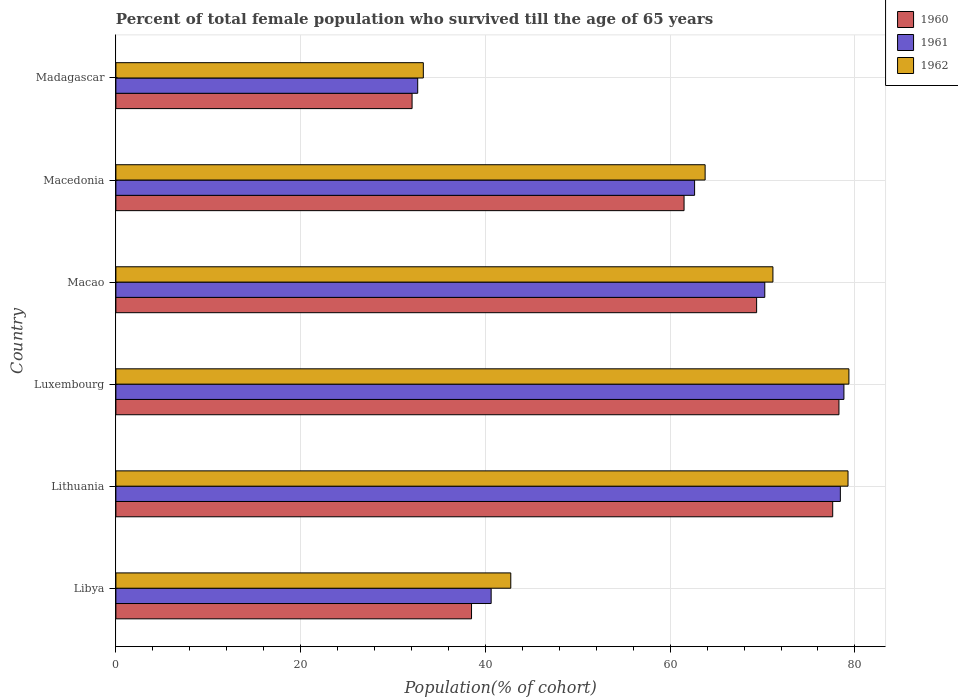How many groups of bars are there?
Make the answer very short. 6. Are the number of bars per tick equal to the number of legend labels?
Give a very brief answer. Yes. How many bars are there on the 4th tick from the top?
Your response must be concise. 3. How many bars are there on the 3rd tick from the bottom?
Offer a very short reply. 3. What is the label of the 2nd group of bars from the top?
Offer a very short reply. Macedonia. What is the percentage of total female population who survived till the age of 65 years in 1961 in Luxembourg?
Provide a short and direct response. 78.81. Across all countries, what is the maximum percentage of total female population who survived till the age of 65 years in 1961?
Your answer should be compact. 78.81. Across all countries, what is the minimum percentage of total female population who survived till the age of 65 years in 1960?
Provide a short and direct response. 32.06. In which country was the percentage of total female population who survived till the age of 65 years in 1961 maximum?
Provide a succinct answer. Luxembourg. In which country was the percentage of total female population who survived till the age of 65 years in 1960 minimum?
Your answer should be compact. Madagascar. What is the total percentage of total female population who survived till the age of 65 years in 1961 in the graph?
Your answer should be very brief. 363.42. What is the difference between the percentage of total female population who survived till the age of 65 years in 1962 in Lithuania and that in Madagascar?
Keep it short and to the point. 45.97. What is the difference between the percentage of total female population who survived till the age of 65 years in 1961 in Libya and the percentage of total female population who survived till the age of 65 years in 1960 in Lithuania?
Your answer should be very brief. -36.97. What is the average percentage of total female population who survived till the age of 65 years in 1960 per country?
Your answer should be very brief. 59.55. What is the difference between the percentage of total female population who survived till the age of 65 years in 1961 and percentage of total female population who survived till the age of 65 years in 1960 in Madagascar?
Offer a terse response. 0.61. In how many countries, is the percentage of total female population who survived till the age of 65 years in 1961 greater than 32 %?
Offer a very short reply. 6. What is the ratio of the percentage of total female population who survived till the age of 65 years in 1960 in Macedonia to that in Madagascar?
Keep it short and to the point. 1.92. What is the difference between the highest and the second highest percentage of total female population who survived till the age of 65 years in 1962?
Offer a terse response. 0.1. What is the difference between the highest and the lowest percentage of total female population who survived till the age of 65 years in 1961?
Provide a succinct answer. 46.14. In how many countries, is the percentage of total female population who survived till the age of 65 years in 1961 greater than the average percentage of total female population who survived till the age of 65 years in 1961 taken over all countries?
Provide a succinct answer. 4. Is it the case that in every country, the sum of the percentage of total female population who survived till the age of 65 years in 1960 and percentage of total female population who survived till the age of 65 years in 1961 is greater than the percentage of total female population who survived till the age of 65 years in 1962?
Provide a succinct answer. Yes. Are all the bars in the graph horizontal?
Your response must be concise. Yes. How many countries are there in the graph?
Your answer should be very brief. 6. What is the difference between two consecutive major ticks on the X-axis?
Your response must be concise. 20. Are the values on the major ticks of X-axis written in scientific E-notation?
Offer a very short reply. No. Does the graph contain grids?
Provide a succinct answer. Yes. Where does the legend appear in the graph?
Make the answer very short. Top right. What is the title of the graph?
Keep it short and to the point. Percent of total female population who survived till the age of 65 years. Does "1993" appear as one of the legend labels in the graph?
Offer a terse response. No. What is the label or title of the X-axis?
Your response must be concise. Population(% of cohort). What is the label or title of the Y-axis?
Make the answer very short. Country. What is the Population(% of cohort) in 1960 in Libya?
Give a very brief answer. 38.5. What is the Population(% of cohort) in 1961 in Libya?
Your response must be concise. 40.62. What is the Population(% of cohort) in 1962 in Libya?
Ensure brevity in your answer.  42.75. What is the Population(% of cohort) of 1960 in Lithuania?
Your response must be concise. 77.6. What is the Population(% of cohort) of 1961 in Lithuania?
Give a very brief answer. 78.43. What is the Population(% of cohort) of 1962 in Lithuania?
Provide a succinct answer. 79.25. What is the Population(% of cohort) in 1960 in Luxembourg?
Give a very brief answer. 78.27. What is the Population(% of cohort) of 1961 in Luxembourg?
Your answer should be very brief. 78.81. What is the Population(% of cohort) of 1962 in Luxembourg?
Offer a terse response. 79.35. What is the Population(% of cohort) of 1960 in Macao?
Provide a short and direct response. 69.36. What is the Population(% of cohort) in 1961 in Macao?
Your answer should be compact. 70.24. What is the Population(% of cohort) of 1962 in Macao?
Provide a short and direct response. 71.13. What is the Population(% of cohort) in 1960 in Macedonia?
Provide a succinct answer. 61.51. What is the Population(% of cohort) of 1961 in Macedonia?
Keep it short and to the point. 62.65. What is the Population(% of cohort) in 1962 in Macedonia?
Keep it short and to the point. 63.79. What is the Population(% of cohort) in 1960 in Madagascar?
Ensure brevity in your answer.  32.06. What is the Population(% of cohort) of 1961 in Madagascar?
Your response must be concise. 32.67. What is the Population(% of cohort) in 1962 in Madagascar?
Your answer should be compact. 33.28. Across all countries, what is the maximum Population(% of cohort) in 1960?
Ensure brevity in your answer.  78.27. Across all countries, what is the maximum Population(% of cohort) in 1961?
Make the answer very short. 78.81. Across all countries, what is the maximum Population(% of cohort) in 1962?
Ensure brevity in your answer.  79.35. Across all countries, what is the minimum Population(% of cohort) in 1960?
Ensure brevity in your answer.  32.06. Across all countries, what is the minimum Population(% of cohort) of 1961?
Your answer should be very brief. 32.67. Across all countries, what is the minimum Population(% of cohort) in 1962?
Offer a very short reply. 33.28. What is the total Population(% of cohort) in 1960 in the graph?
Offer a terse response. 357.3. What is the total Population(% of cohort) in 1961 in the graph?
Keep it short and to the point. 363.42. What is the total Population(% of cohort) in 1962 in the graph?
Give a very brief answer. 369.55. What is the difference between the Population(% of cohort) of 1960 in Libya and that in Lithuania?
Keep it short and to the point. -39.1. What is the difference between the Population(% of cohort) in 1961 in Libya and that in Lithuania?
Ensure brevity in your answer.  -37.8. What is the difference between the Population(% of cohort) of 1962 in Libya and that in Lithuania?
Your answer should be very brief. -36.51. What is the difference between the Population(% of cohort) of 1960 in Libya and that in Luxembourg?
Your answer should be compact. -39.77. What is the difference between the Population(% of cohort) of 1961 in Libya and that in Luxembourg?
Provide a short and direct response. -38.19. What is the difference between the Population(% of cohort) in 1962 in Libya and that in Luxembourg?
Your answer should be compact. -36.6. What is the difference between the Population(% of cohort) in 1960 in Libya and that in Macao?
Ensure brevity in your answer.  -30.86. What is the difference between the Population(% of cohort) in 1961 in Libya and that in Macao?
Make the answer very short. -29.62. What is the difference between the Population(% of cohort) of 1962 in Libya and that in Macao?
Your answer should be very brief. -28.38. What is the difference between the Population(% of cohort) in 1960 in Libya and that in Macedonia?
Make the answer very short. -23.01. What is the difference between the Population(% of cohort) in 1961 in Libya and that in Macedonia?
Provide a short and direct response. -22.02. What is the difference between the Population(% of cohort) in 1962 in Libya and that in Macedonia?
Make the answer very short. -21.04. What is the difference between the Population(% of cohort) of 1960 in Libya and that in Madagascar?
Your answer should be compact. 6.43. What is the difference between the Population(% of cohort) in 1961 in Libya and that in Madagascar?
Give a very brief answer. 7.95. What is the difference between the Population(% of cohort) in 1962 in Libya and that in Madagascar?
Provide a short and direct response. 9.47. What is the difference between the Population(% of cohort) of 1960 in Lithuania and that in Luxembourg?
Ensure brevity in your answer.  -0.68. What is the difference between the Population(% of cohort) in 1961 in Lithuania and that in Luxembourg?
Your answer should be very brief. -0.39. What is the difference between the Population(% of cohort) in 1962 in Lithuania and that in Luxembourg?
Your response must be concise. -0.1. What is the difference between the Population(% of cohort) in 1960 in Lithuania and that in Macao?
Keep it short and to the point. 8.24. What is the difference between the Population(% of cohort) of 1961 in Lithuania and that in Macao?
Ensure brevity in your answer.  8.18. What is the difference between the Population(% of cohort) in 1962 in Lithuania and that in Macao?
Keep it short and to the point. 8.13. What is the difference between the Population(% of cohort) of 1960 in Lithuania and that in Macedonia?
Offer a terse response. 16.09. What is the difference between the Population(% of cohort) of 1961 in Lithuania and that in Macedonia?
Your answer should be compact. 15.78. What is the difference between the Population(% of cohort) in 1962 in Lithuania and that in Macedonia?
Make the answer very short. 15.47. What is the difference between the Population(% of cohort) of 1960 in Lithuania and that in Madagascar?
Give a very brief answer. 45.53. What is the difference between the Population(% of cohort) of 1961 in Lithuania and that in Madagascar?
Ensure brevity in your answer.  45.75. What is the difference between the Population(% of cohort) of 1962 in Lithuania and that in Madagascar?
Give a very brief answer. 45.97. What is the difference between the Population(% of cohort) of 1960 in Luxembourg and that in Macao?
Provide a succinct answer. 8.91. What is the difference between the Population(% of cohort) in 1961 in Luxembourg and that in Macao?
Make the answer very short. 8.57. What is the difference between the Population(% of cohort) of 1962 in Luxembourg and that in Macao?
Your answer should be compact. 8.22. What is the difference between the Population(% of cohort) in 1960 in Luxembourg and that in Macedonia?
Provide a short and direct response. 16.77. What is the difference between the Population(% of cohort) in 1961 in Luxembourg and that in Macedonia?
Provide a short and direct response. 16.17. What is the difference between the Population(% of cohort) of 1962 in Luxembourg and that in Macedonia?
Offer a terse response. 15.56. What is the difference between the Population(% of cohort) of 1960 in Luxembourg and that in Madagascar?
Ensure brevity in your answer.  46.21. What is the difference between the Population(% of cohort) of 1961 in Luxembourg and that in Madagascar?
Provide a succinct answer. 46.14. What is the difference between the Population(% of cohort) in 1962 in Luxembourg and that in Madagascar?
Ensure brevity in your answer.  46.07. What is the difference between the Population(% of cohort) in 1960 in Macao and that in Macedonia?
Offer a very short reply. 7.85. What is the difference between the Population(% of cohort) of 1961 in Macao and that in Macedonia?
Keep it short and to the point. 7.6. What is the difference between the Population(% of cohort) in 1962 in Macao and that in Macedonia?
Provide a short and direct response. 7.34. What is the difference between the Population(% of cohort) in 1960 in Macao and that in Madagascar?
Provide a succinct answer. 37.3. What is the difference between the Population(% of cohort) in 1961 in Macao and that in Madagascar?
Offer a very short reply. 37.57. What is the difference between the Population(% of cohort) of 1962 in Macao and that in Madagascar?
Provide a short and direct response. 37.85. What is the difference between the Population(% of cohort) of 1960 in Macedonia and that in Madagascar?
Give a very brief answer. 29.44. What is the difference between the Population(% of cohort) of 1961 in Macedonia and that in Madagascar?
Keep it short and to the point. 29.97. What is the difference between the Population(% of cohort) in 1962 in Macedonia and that in Madagascar?
Your response must be concise. 30.51. What is the difference between the Population(% of cohort) in 1960 in Libya and the Population(% of cohort) in 1961 in Lithuania?
Ensure brevity in your answer.  -39.93. What is the difference between the Population(% of cohort) in 1960 in Libya and the Population(% of cohort) in 1962 in Lithuania?
Offer a terse response. -40.76. What is the difference between the Population(% of cohort) in 1961 in Libya and the Population(% of cohort) in 1962 in Lithuania?
Keep it short and to the point. -38.63. What is the difference between the Population(% of cohort) in 1960 in Libya and the Population(% of cohort) in 1961 in Luxembourg?
Your answer should be very brief. -40.31. What is the difference between the Population(% of cohort) of 1960 in Libya and the Population(% of cohort) of 1962 in Luxembourg?
Offer a very short reply. -40.85. What is the difference between the Population(% of cohort) of 1961 in Libya and the Population(% of cohort) of 1962 in Luxembourg?
Your response must be concise. -38.73. What is the difference between the Population(% of cohort) in 1960 in Libya and the Population(% of cohort) in 1961 in Macao?
Provide a succinct answer. -31.75. What is the difference between the Population(% of cohort) of 1960 in Libya and the Population(% of cohort) of 1962 in Macao?
Your answer should be very brief. -32.63. What is the difference between the Population(% of cohort) in 1961 in Libya and the Population(% of cohort) in 1962 in Macao?
Offer a very short reply. -30.5. What is the difference between the Population(% of cohort) in 1960 in Libya and the Population(% of cohort) in 1961 in Macedonia?
Your answer should be compact. -24.15. What is the difference between the Population(% of cohort) in 1960 in Libya and the Population(% of cohort) in 1962 in Macedonia?
Provide a short and direct response. -25.29. What is the difference between the Population(% of cohort) of 1961 in Libya and the Population(% of cohort) of 1962 in Macedonia?
Your answer should be very brief. -23.16. What is the difference between the Population(% of cohort) of 1960 in Libya and the Population(% of cohort) of 1961 in Madagascar?
Your answer should be very brief. 5.83. What is the difference between the Population(% of cohort) in 1960 in Libya and the Population(% of cohort) in 1962 in Madagascar?
Provide a short and direct response. 5.22. What is the difference between the Population(% of cohort) of 1961 in Libya and the Population(% of cohort) of 1962 in Madagascar?
Keep it short and to the point. 7.34. What is the difference between the Population(% of cohort) of 1960 in Lithuania and the Population(% of cohort) of 1961 in Luxembourg?
Offer a very short reply. -1.22. What is the difference between the Population(% of cohort) of 1960 in Lithuania and the Population(% of cohort) of 1962 in Luxembourg?
Ensure brevity in your answer.  -1.75. What is the difference between the Population(% of cohort) in 1961 in Lithuania and the Population(% of cohort) in 1962 in Luxembourg?
Keep it short and to the point. -0.93. What is the difference between the Population(% of cohort) in 1960 in Lithuania and the Population(% of cohort) in 1961 in Macao?
Give a very brief answer. 7.35. What is the difference between the Population(% of cohort) in 1960 in Lithuania and the Population(% of cohort) in 1962 in Macao?
Your answer should be compact. 6.47. What is the difference between the Population(% of cohort) of 1961 in Lithuania and the Population(% of cohort) of 1962 in Macao?
Your answer should be compact. 7.3. What is the difference between the Population(% of cohort) of 1960 in Lithuania and the Population(% of cohort) of 1961 in Macedonia?
Offer a terse response. 14.95. What is the difference between the Population(% of cohort) in 1960 in Lithuania and the Population(% of cohort) in 1962 in Macedonia?
Provide a succinct answer. 13.81. What is the difference between the Population(% of cohort) in 1961 in Lithuania and the Population(% of cohort) in 1962 in Macedonia?
Provide a succinct answer. 14.64. What is the difference between the Population(% of cohort) in 1960 in Lithuania and the Population(% of cohort) in 1961 in Madagascar?
Provide a succinct answer. 44.92. What is the difference between the Population(% of cohort) in 1960 in Lithuania and the Population(% of cohort) in 1962 in Madagascar?
Keep it short and to the point. 44.32. What is the difference between the Population(% of cohort) of 1961 in Lithuania and the Population(% of cohort) of 1962 in Madagascar?
Keep it short and to the point. 45.14. What is the difference between the Population(% of cohort) of 1960 in Luxembourg and the Population(% of cohort) of 1961 in Macao?
Keep it short and to the point. 8.03. What is the difference between the Population(% of cohort) of 1960 in Luxembourg and the Population(% of cohort) of 1962 in Macao?
Provide a short and direct response. 7.15. What is the difference between the Population(% of cohort) of 1961 in Luxembourg and the Population(% of cohort) of 1962 in Macao?
Provide a succinct answer. 7.69. What is the difference between the Population(% of cohort) in 1960 in Luxembourg and the Population(% of cohort) in 1961 in Macedonia?
Offer a very short reply. 15.63. What is the difference between the Population(% of cohort) of 1960 in Luxembourg and the Population(% of cohort) of 1962 in Macedonia?
Ensure brevity in your answer.  14.49. What is the difference between the Population(% of cohort) in 1961 in Luxembourg and the Population(% of cohort) in 1962 in Macedonia?
Provide a short and direct response. 15.03. What is the difference between the Population(% of cohort) of 1960 in Luxembourg and the Population(% of cohort) of 1961 in Madagascar?
Your response must be concise. 45.6. What is the difference between the Population(% of cohort) of 1960 in Luxembourg and the Population(% of cohort) of 1962 in Madagascar?
Your answer should be very brief. 44.99. What is the difference between the Population(% of cohort) of 1961 in Luxembourg and the Population(% of cohort) of 1962 in Madagascar?
Your response must be concise. 45.53. What is the difference between the Population(% of cohort) of 1960 in Macao and the Population(% of cohort) of 1961 in Macedonia?
Provide a short and direct response. 6.71. What is the difference between the Population(% of cohort) of 1960 in Macao and the Population(% of cohort) of 1962 in Macedonia?
Your answer should be compact. 5.57. What is the difference between the Population(% of cohort) of 1961 in Macao and the Population(% of cohort) of 1962 in Macedonia?
Provide a succinct answer. 6.46. What is the difference between the Population(% of cohort) of 1960 in Macao and the Population(% of cohort) of 1961 in Madagascar?
Keep it short and to the point. 36.69. What is the difference between the Population(% of cohort) in 1960 in Macao and the Population(% of cohort) in 1962 in Madagascar?
Your answer should be very brief. 36.08. What is the difference between the Population(% of cohort) of 1961 in Macao and the Population(% of cohort) of 1962 in Madagascar?
Your answer should be compact. 36.96. What is the difference between the Population(% of cohort) of 1960 in Macedonia and the Population(% of cohort) of 1961 in Madagascar?
Your answer should be compact. 28.83. What is the difference between the Population(% of cohort) in 1960 in Macedonia and the Population(% of cohort) in 1962 in Madagascar?
Offer a terse response. 28.23. What is the difference between the Population(% of cohort) in 1961 in Macedonia and the Population(% of cohort) in 1962 in Madagascar?
Make the answer very short. 29.37. What is the average Population(% of cohort) in 1960 per country?
Offer a terse response. 59.55. What is the average Population(% of cohort) of 1961 per country?
Make the answer very short. 60.57. What is the average Population(% of cohort) of 1962 per country?
Your answer should be compact. 61.59. What is the difference between the Population(% of cohort) in 1960 and Population(% of cohort) in 1961 in Libya?
Make the answer very short. -2.12. What is the difference between the Population(% of cohort) of 1960 and Population(% of cohort) of 1962 in Libya?
Your answer should be compact. -4.25. What is the difference between the Population(% of cohort) of 1961 and Population(% of cohort) of 1962 in Libya?
Offer a terse response. -2.12. What is the difference between the Population(% of cohort) of 1960 and Population(% of cohort) of 1961 in Lithuania?
Keep it short and to the point. -0.83. What is the difference between the Population(% of cohort) of 1960 and Population(% of cohort) of 1962 in Lithuania?
Your answer should be very brief. -1.66. What is the difference between the Population(% of cohort) of 1961 and Population(% of cohort) of 1962 in Lithuania?
Your answer should be very brief. -0.83. What is the difference between the Population(% of cohort) in 1960 and Population(% of cohort) in 1961 in Luxembourg?
Your response must be concise. -0.54. What is the difference between the Population(% of cohort) in 1960 and Population(% of cohort) in 1962 in Luxembourg?
Your answer should be compact. -1.08. What is the difference between the Population(% of cohort) of 1961 and Population(% of cohort) of 1962 in Luxembourg?
Provide a succinct answer. -0.54. What is the difference between the Population(% of cohort) in 1960 and Population(% of cohort) in 1961 in Macao?
Offer a very short reply. -0.88. What is the difference between the Population(% of cohort) in 1960 and Population(% of cohort) in 1962 in Macao?
Offer a very short reply. -1.77. What is the difference between the Population(% of cohort) of 1961 and Population(% of cohort) of 1962 in Macao?
Your answer should be compact. -0.88. What is the difference between the Population(% of cohort) of 1960 and Population(% of cohort) of 1961 in Macedonia?
Offer a very short reply. -1.14. What is the difference between the Population(% of cohort) in 1960 and Population(% of cohort) in 1962 in Macedonia?
Provide a short and direct response. -2.28. What is the difference between the Population(% of cohort) in 1961 and Population(% of cohort) in 1962 in Macedonia?
Your response must be concise. -1.14. What is the difference between the Population(% of cohort) of 1960 and Population(% of cohort) of 1961 in Madagascar?
Your answer should be compact. -0.61. What is the difference between the Population(% of cohort) of 1960 and Population(% of cohort) of 1962 in Madagascar?
Ensure brevity in your answer.  -1.22. What is the difference between the Population(% of cohort) of 1961 and Population(% of cohort) of 1962 in Madagascar?
Offer a terse response. -0.61. What is the ratio of the Population(% of cohort) in 1960 in Libya to that in Lithuania?
Offer a terse response. 0.5. What is the ratio of the Population(% of cohort) of 1961 in Libya to that in Lithuania?
Offer a very short reply. 0.52. What is the ratio of the Population(% of cohort) in 1962 in Libya to that in Lithuania?
Provide a succinct answer. 0.54. What is the ratio of the Population(% of cohort) in 1960 in Libya to that in Luxembourg?
Provide a succinct answer. 0.49. What is the ratio of the Population(% of cohort) in 1961 in Libya to that in Luxembourg?
Provide a succinct answer. 0.52. What is the ratio of the Population(% of cohort) of 1962 in Libya to that in Luxembourg?
Your response must be concise. 0.54. What is the ratio of the Population(% of cohort) in 1960 in Libya to that in Macao?
Your answer should be compact. 0.56. What is the ratio of the Population(% of cohort) of 1961 in Libya to that in Macao?
Provide a succinct answer. 0.58. What is the ratio of the Population(% of cohort) of 1962 in Libya to that in Macao?
Make the answer very short. 0.6. What is the ratio of the Population(% of cohort) in 1960 in Libya to that in Macedonia?
Give a very brief answer. 0.63. What is the ratio of the Population(% of cohort) of 1961 in Libya to that in Macedonia?
Your response must be concise. 0.65. What is the ratio of the Population(% of cohort) of 1962 in Libya to that in Macedonia?
Provide a succinct answer. 0.67. What is the ratio of the Population(% of cohort) of 1960 in Libya to that in Madagascar?
Provide a short and direct response. 1.2. What is the ratio of the Population(% of cohort) of 1961 in Libya to that in Madagascar?
Give a very brief answer. 1.24. What is the ratio of the Population(% of cohort) of 1962 in Libya to that in Madagascar?
Your response must be concise. 1.28. What is the ratio of the Population(% of cohort) of 1960 in Lithuania to that in Luxembourg?
Your answer should be compact. 0.99. What is the ratio of the Population(% of cohort) in 1961 in Lithuania to that in Luxembourg?
Your answer should be very brief. 1. What is the ratio of the Population(% of cohort) in 1962 in Lithuania to that in Luxembourg?
Your answer should be compact. 1. What is the ratio of the Population(% of cohort) in 1960 in Lithuania to that in Macao?
Your answer should be compact. 1.12. What is the ratio of the Population(% of cohort) of 1961 in Lithuania to that in Macao?
Provide a short and direct response. 1.12. What is the ratio of the Population(% of cohort) of 1962 in Lithuania to that in Macao?
Offer a very short reply. 1.11. What is the ratio of the Population(% of cohort) in 1960 in Lithuania to that in Macedonia?
Your answer should be very brief. 1.26. What is the ratio of the Population(% of cohort) of 1961 in Lithuania to that in Macedonia?
Offer a very short reply. 1.25. What is the ratio of the Population(% of cohort) in 1962 in Lithuania to that in Macedonia?
Make the answer very short. 1.24. What is the ratio of the Population(% of cohort) of 1960 in Lithuania to that in Madagascar?
Provide a short and direct response. 2.42. What is the ratio of the Population(% of cohort) in 1961 in Lithuania to that in Madagascar?
Offer a terse response. 2.4. What is the ratio of the Population(% of cohort) in 1962 in Lithuania to that in Madagascar?
Keep it short and to the point. 2.38. What is the ratio of the Population(% of cohort) of 1960 in Luxembourg to that in Macao?
Your answer should be very brief. 1.13. What is the ratio of the Population(% of cohort) in 1961 in Luxembourg to that in Macao?
Your response must be concise. 1.12. What is the ratio of the Population(% of cohort) in 1962 in Luxembourg to that in Macao?
Give a very brief answer. 1.12. What is the ratio of the Population(% of cohort) of 1960 in Luxembourg to that in Macedonia?
Provide a succinct answer. 1.27. What is the ratio of the Population(% of cohort) of 1961 in Luxembourg to that in Macedonia?
Keep it short and to the point. 1.26. What is the ratio of the Population(% of cohort) of 1962 in Luxembourg to that in Macedonia?
Keep it short and to the point. 1.24. What is the ratio of the Population(% of cohort) of 1960 in Luxembourg to that in Madagascar?
Your response must be concise. 2.44. What is the ratio of the Population(% of cohort) in 1961 in Luxembourg to that in Madagascar?
Make the answer very short. 2.41. What is the ratio of the Population(% of cohort) in 1962 in Luxembourg to that in Madagascar?
Your answer should be compact. 2.38. What is the ratio of the Population(% of cohort) in 1960 in Macao to that in Macedonia?
Your answer should be very brief. 1.13. What is the ratio of the Population(% of cohort) in 1961 in Macao to that in Macedonia?
Offer a very short reply. 1.12. What is the ratio of the Population(% of cohort) in 1962 in Macao to that in Macedonia?
Make the answer very short. 1.12. What is the ratio of the Population(% of cohort) of 1960 in Macao to that in Madagascar?
Your answer should be compact. 2.16. What is the ratio of the Population(% of cohort) in 1961 in Macao to that in Madagascar?
Make the answer very short. 2.15. What is the ratio of the Population(% of cohort) in 1962 in Macao to that in Madagascar?
Your answer should be compact. 2.14. What is the ratio of the Population(% of cohort) in 1960 in Macedonia to that in Madagascar?
Your answer should be compact. 1.92. What is the ratio of the Population(% of cohort) of 1961 in Macedonia to that in Madagascar?
Provide a succinct answer. 1.92. What is the ratio of the Population(% of cohort) of 1962 in Macedonia to that in Madagascar?
Provide a short and direct response. 1.92. What is the difference between the highest and the second highest Population(% of cohort) in 1960?
Provide a short and direct response. 0.68. What is the difference between the highest and the second highest Population(% of cohort) in 1961?
Give a very brief answer. 0.39. What is the difference between the highest and the second highest Population(% of cohort) of 1962?
Make the answer very short. 0.1. What is the difference between the highest and the lowest Population(% of cohort) of 1960?
Offer a terse response. 46.21. What is the difference between the highest and the lowest Population(% of cohort) of 1961?
Ensure brevity in your answer.  46.14. What is the difference between the highest and the lowest Population(% of cohort) of 1962?
Offer a very short reply. 46.07. 